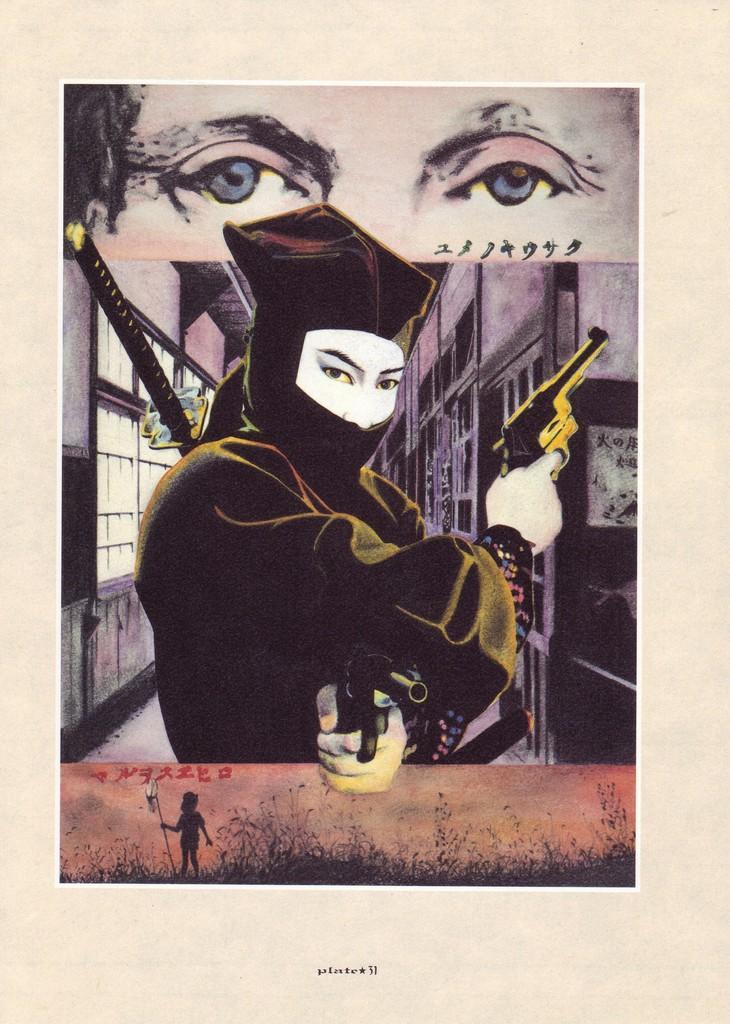Describe this image in one or two sentences. In this image I can see the photo on the cream color surface. In the photo I can see the person holding the guns and I can see the building in the back. I can also see the person's eyes and the grass in the image. 